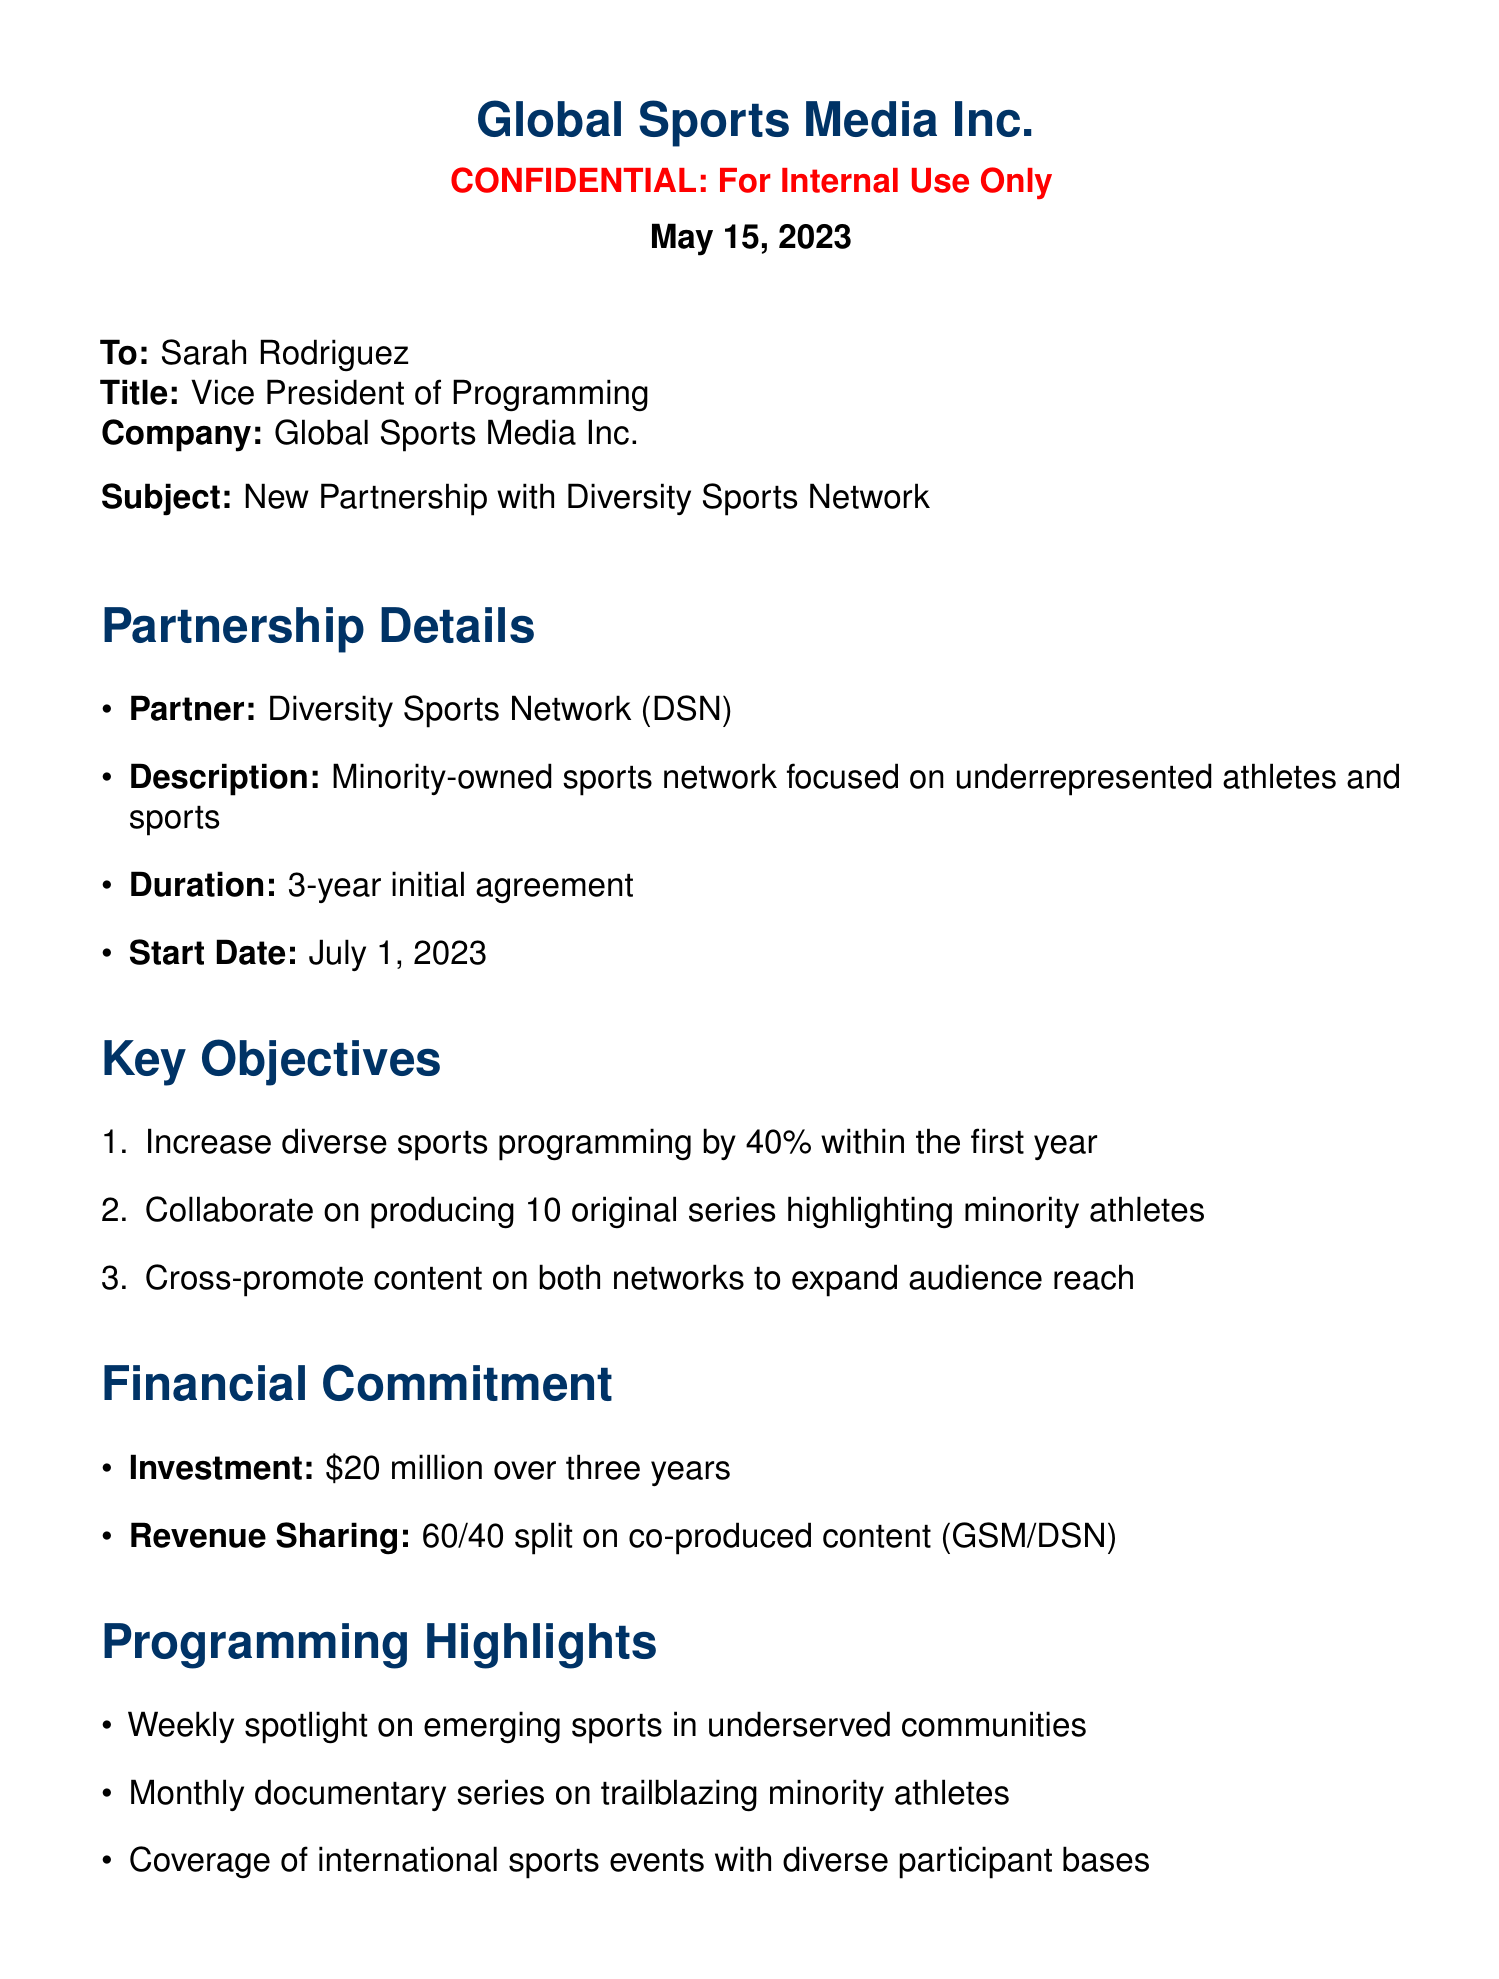what is the name of the partner network? The partner network is explicitly mentioned in the document as Diversity Sports Network (DSN).
Answer: Diversity Sports Network (DSN) what is the duration of the partnership? The document specifies that the duration of the partnership is a 3-year initial agreement.
Answer: 3-year what is the financial commitment amount? The document outlines the financial commitment as $20 million over three years.
Answer: $20 million how much diverse sports programming is expected to increase in the first year? The document states the objective is to increase diverse sports programming by 40% within the first year.
Answer: 40% what is one key objective related to original series? The document mentions a goal to collaborate on producing 10 original series highlighting minority athletes.
Answer: 10 original series what is the revenue sharing split format? The document explains the revenue sharing as a 60/40 split on co-produced content.
Answer: 60/40 split when is the press release expected to be announced? The document notes that the joint press release is scheduled for announcement on June 1, 2023.
Answer: June 1, 2023 who is the CEO of Global Sports Media Inc.? The document indicates that the CEO of Global Sports Media Inc. is Michael Chang.
Answer: Michael Chang what is the focus of the Diversity Sports Network? The document describes DSN as a minority-owned sports network focused on underrepresented athletes and sports.
Answer: Underrepresented athletes and sports 